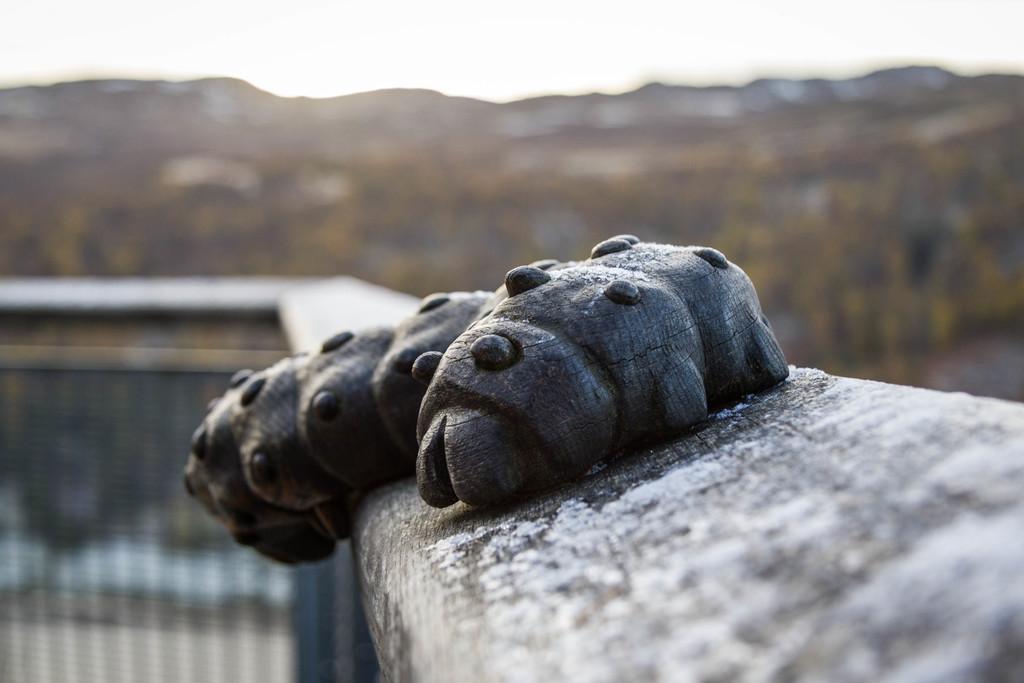In one or two sentences, can you explain what this image depicts? There is an object placed on the fence, this is a sky and plant. 